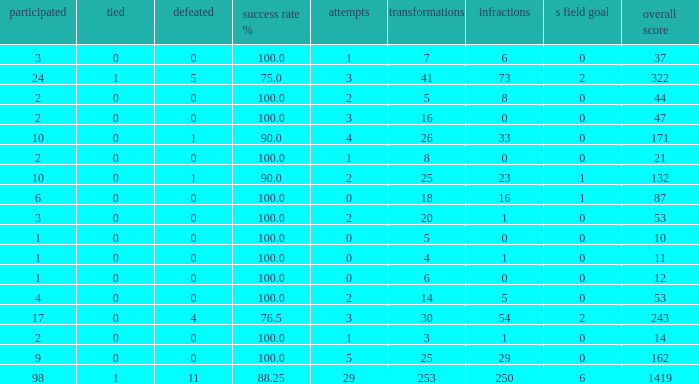What is the smallest amount of penalties he acquired when his points total was above 1419 in beyond 98 matches? None. 